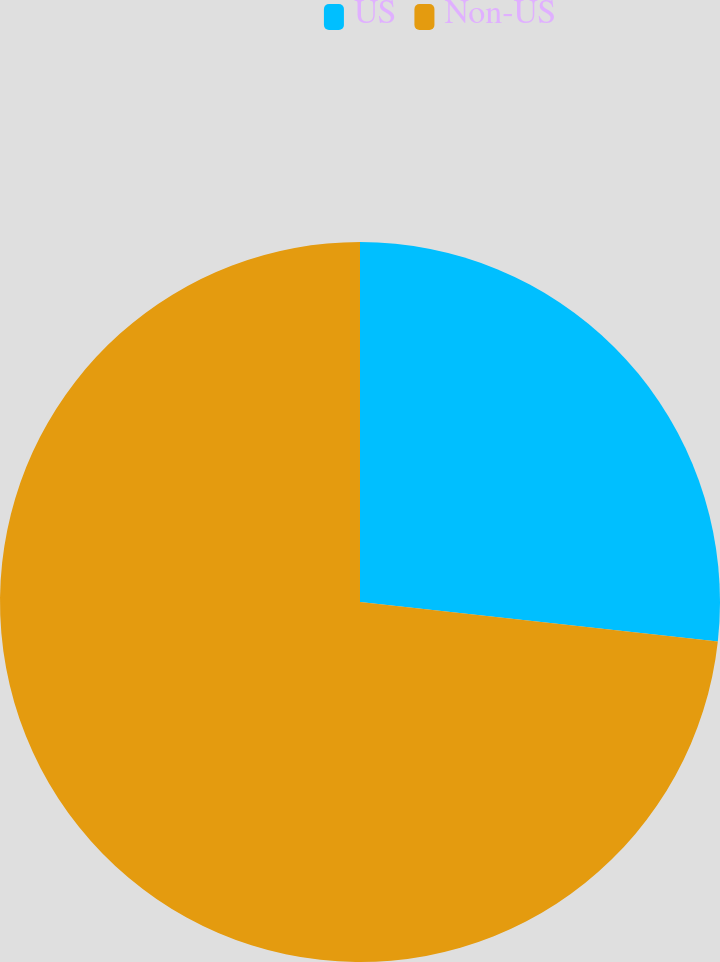Convert chart to OTSL. <chart><loc_0><loc_0><loc_500><loc_500><pie_chart><fcel>US<fcel>Non-US<nl><fcel>26.75%<fcel>73.25%<nl></chart> 